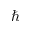<formula> <loc_0><loc_0><loc_500><loc_500>\hbar</formula> 